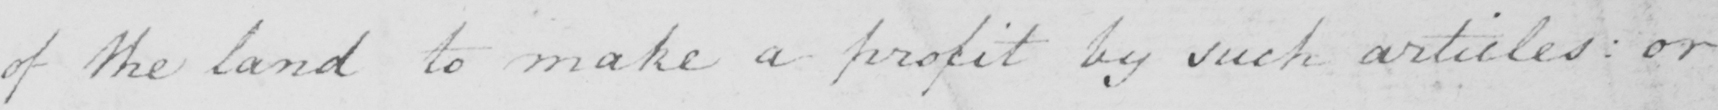Please transcribe the handwritten text in this image. of the land to make a profit by such articles :  or 